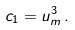Convert formula to latex. <formula><loc_0><loc_0><loc_500><loc_500>c _ { 1 } = u _ { m } ^ { 3 } \, .</formula> 